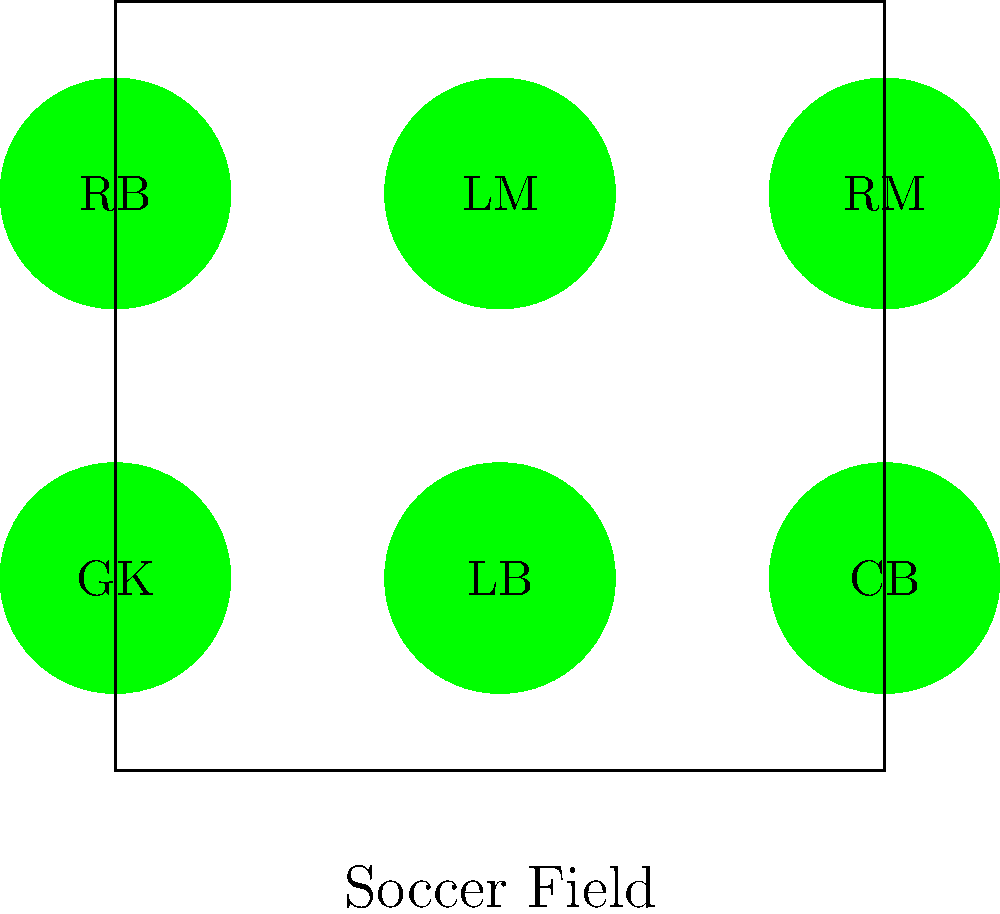MesoAmerica FC's coach is experimenting with different formations for an upcoming California league match. He wants to arrange 6 players (GK, LB, CB, RB, LM, RM) in different positions. How many unique arrangements are possible if the goalkeeper (GK) must always remain in their original position? Let's approach this step-by-step:

1) We have 6 players in total: GK, LB, CB, RB, LM, and RM.

2) The goalkeeper (GK) must remain in their original position. This means we only need to consider the permutations of the other 5 players.

3) When we have n distinct objects, the number of ways to arrange them is given by n! (n factorial).

4) In this case, we have 5 players to arrange (excluding the goalkeeper), so we need to calculate 5!.

5) 5! = 5 × 4 × 3 × 2 × 1 = 120

Therefore, there are 120 unique arrangements possible.

This problem is an application of the permutation group $S_5$, which has order 5! = 120. Each permutation represents a unique arrangement of the 5 outfield players.
Answer: 120 